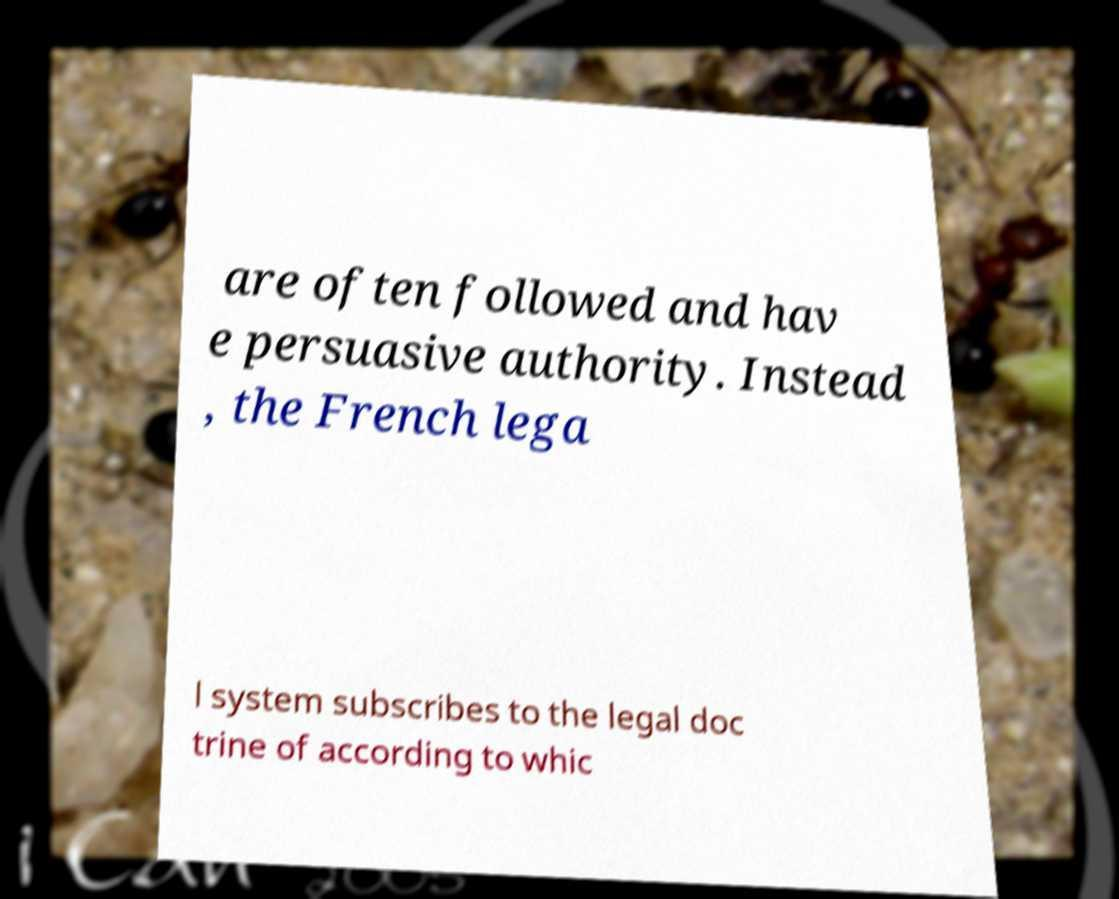Could you assist in decoding the text presented in this image and type it out clearly? are often followed and hav e persuasive authority. Instead , the French lega l system subscribes to the legal doc trine of according to whic 